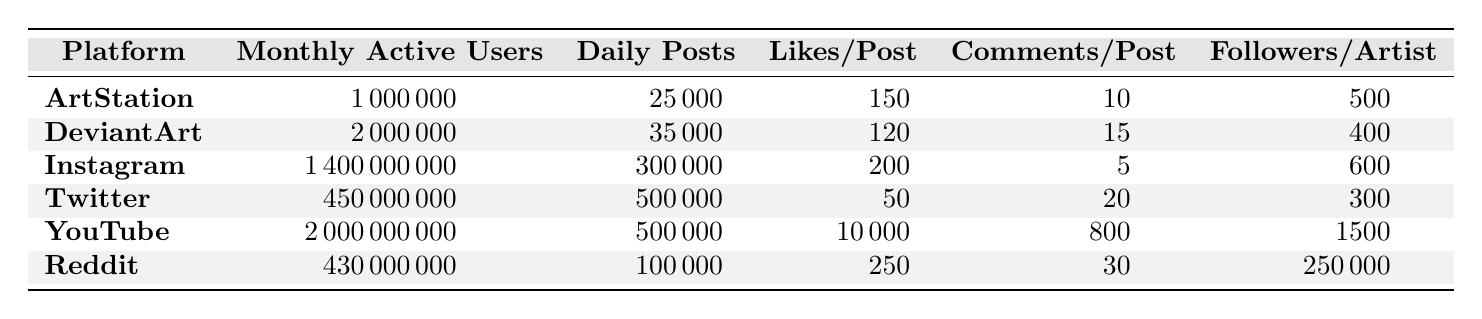What is the platform with the highest monthly active users? Reviewing the data in the table, Instagram has the highest number of monthly active users at 1,400,000,000.
Answer: Instagram How many average daily posts does Twitter have? The table indicates that Twitter has an average of 500,000 daily posts.
Answer: 500,000 On which platform do posts receive the most likes on average? Looking at the average likes per post, Reddit leads with 250 likes per post.
Answer: Reddit What is the difference in average likes per post between Reddit and DeviantArt? Reddit has 250 likes per post and DeviantArt has 120 likes per post. The difference is 250 - 120 = 130.
Answer: 130 Which platform has more followers per artist, Instagram or DeviantArt? According to the data, Instagram has 600 followers per artist, while DeviantArt has 400. Therefore, Instagram has more followers per artist.
Answer: Instagram Is the average number of comments per post on YouTube greater than 10? YouTube has an average of 800 likes per video; however, this does not provide insights on comments. Since YouTube is not specifically in the comments data, the direct comparison can't be made. For posts, it has no set data matching this question.
Answer: No (for comment comparison) What platform has the lowest followers per artist? Comparing all platforms, Reddit has the lowest followers per subreddit at 250, while all others have more.
Answer: Reddit If we sum the average likes per post for ArtStation and DeviantArt, what total do we get? ArtStation has 150 likes per post and DeviantArt has 120 likes per post. Summing these gives 150 + 120 = 270.
Answer: 270 How does the average daily posts on DeviantArt compare to that of Reddit? DeviantArt has 35,000 average daily posts, whereas Reddit has 100,000. Thus, Reddit has more daily posts than DeviantArt.
Answer: Reddit What is the total number of monthly active users across all platforms? Summing the monthly active users gives 1,000,000 + 2,000,000 + 1,400,000,000 + 450,000,000 + 2,000,000,000 + 430,000,000 = 4,982,000,000.
Answer: 4,982,000,000 Which platform has both the highest number of average daily posts and the lowest average likes per post? From the table, Twitter has the highest daily posts (500,000) while having the lowest likes per post (50).
Answer: Twitter 